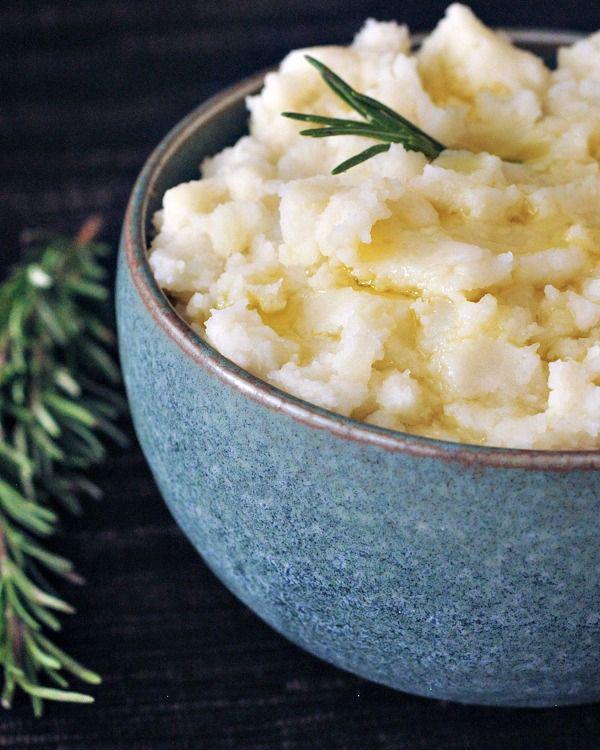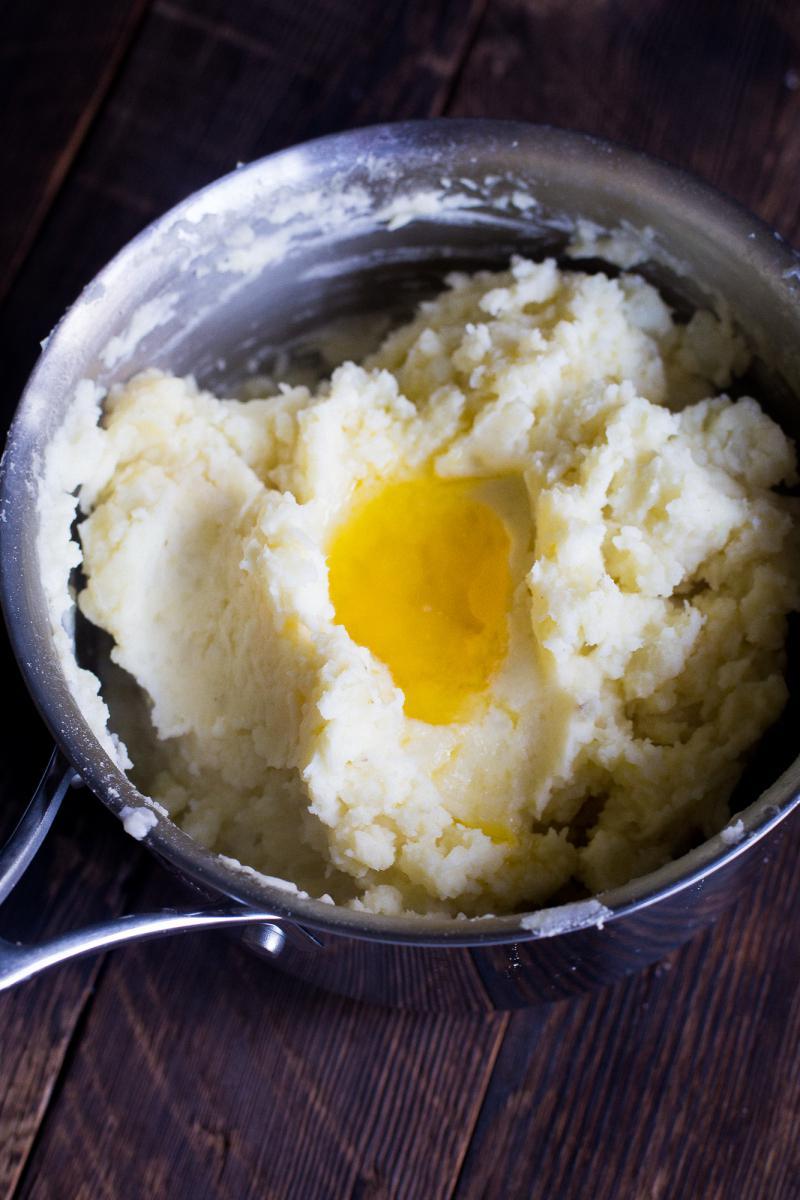The first image is the image on the left, the second image is the image on the right. Given the left and right images, does the statement "A spoon is in a bowl of mashed potatoes in one image." hold true? Answer yes or no. No. The first image is the image on the left, the second image is the image on the right. For the images displayed, is the sentence "In one image, there is a spoon in the mashed potatoes that is resting on the side of the container that the potatoes are in." factually correct? Answer yes or no. No. 